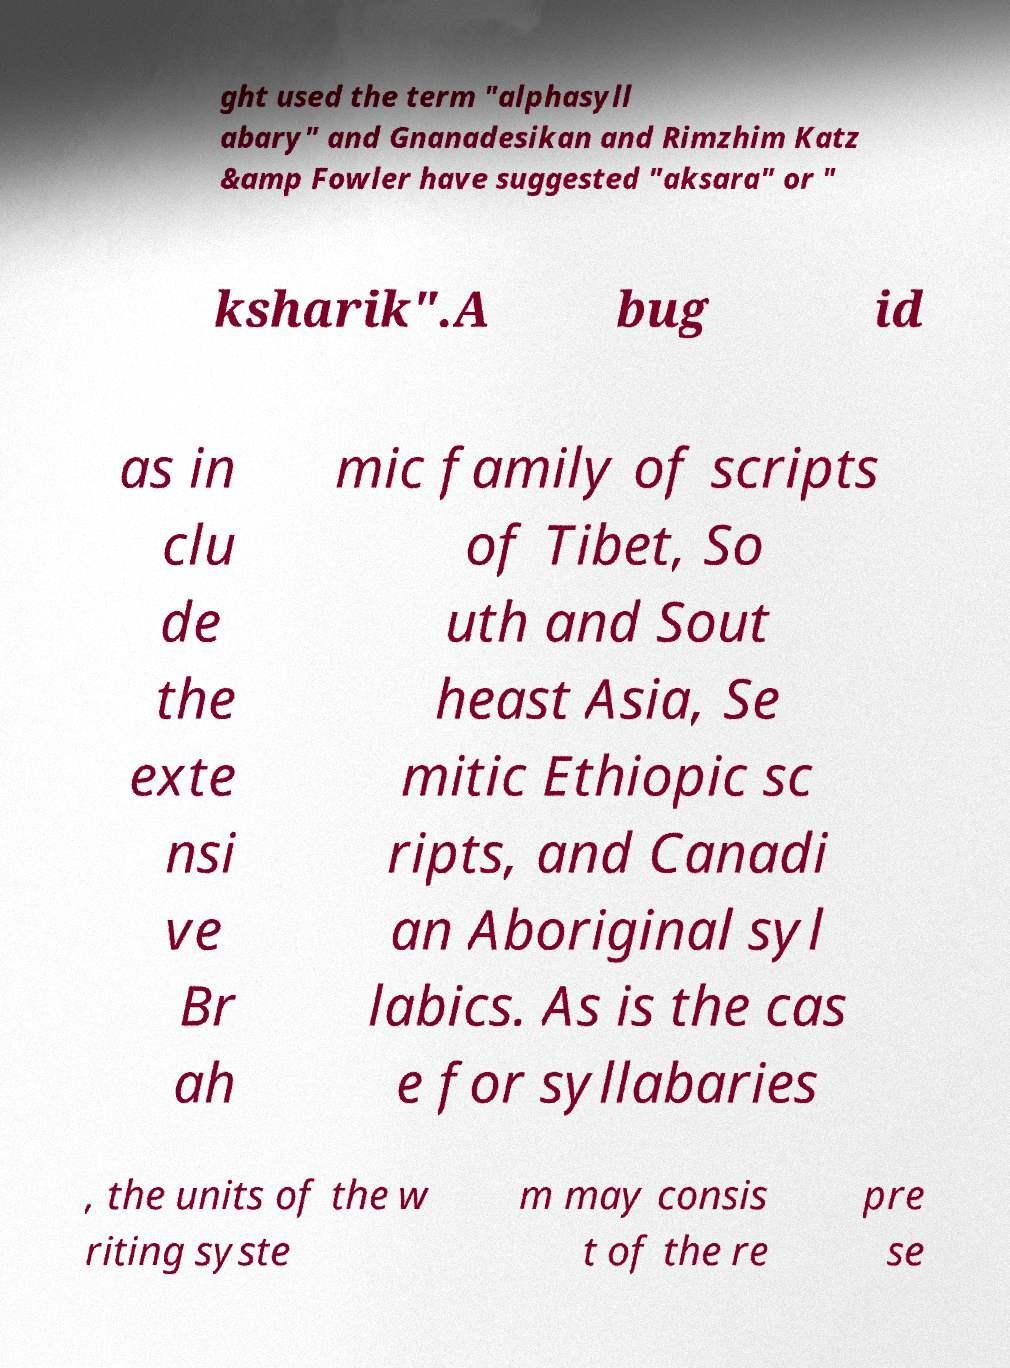Please identify and transcribe the text found in this image. ght used the term "alphasyll abary" and Gnanadesikan and Rimzhim Katz &amp Fowler have suggested "aksara" or " ksharik".A bug id as in clu de the exte nsi ve Br ah mic family of scripts of Tibet, So uth and Sout heast Asia, Se mitic Ethiopic sc ripts, and Canadi an Aboriginal syl labics. As is the cas e for syllabaries , the units of the w riting syste m may consis t of the re pre se 